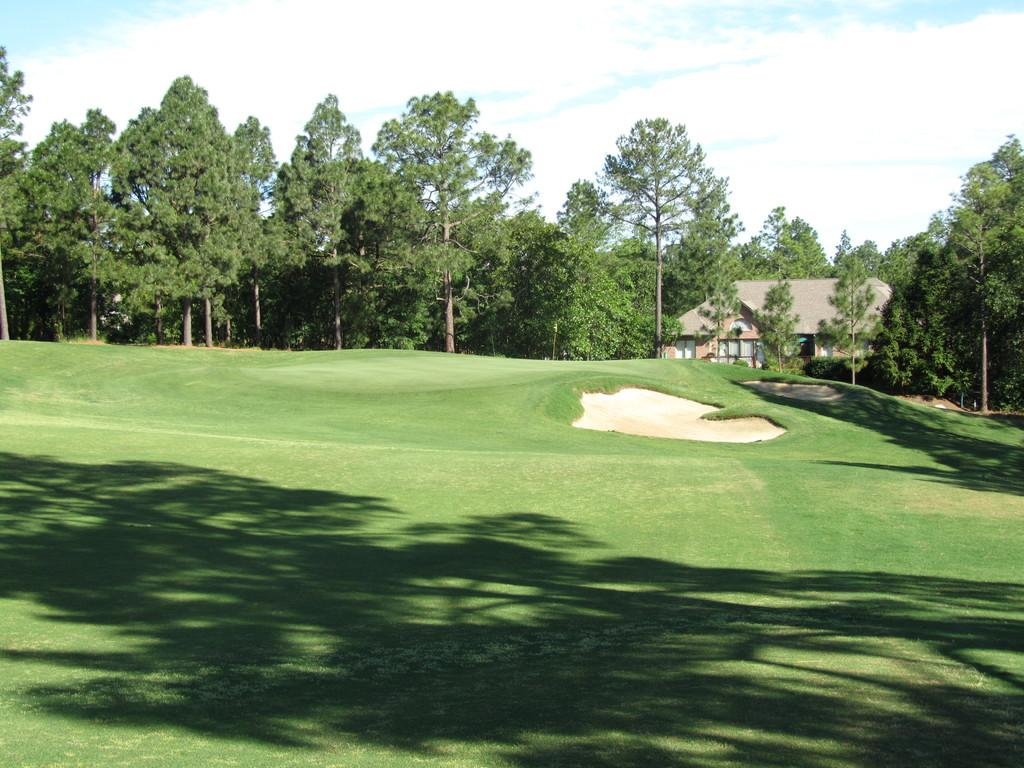What is visible in the sky in the image? The sky with clouds is visible in the image. What type of vegetation can be seen in the image? There are trees in the image. What type of structure is present in the image? There is at least one building in the image. What is visible at the bottom of the image? The ground is visible in the image. How many pies are visible on the branches of the trees in the image? There are no pies present on the branches of the trees in the image. What type of oranges can be seen hanging from the branches of the trees in the image? There are no oranges present on the branches of the trees in the image. 